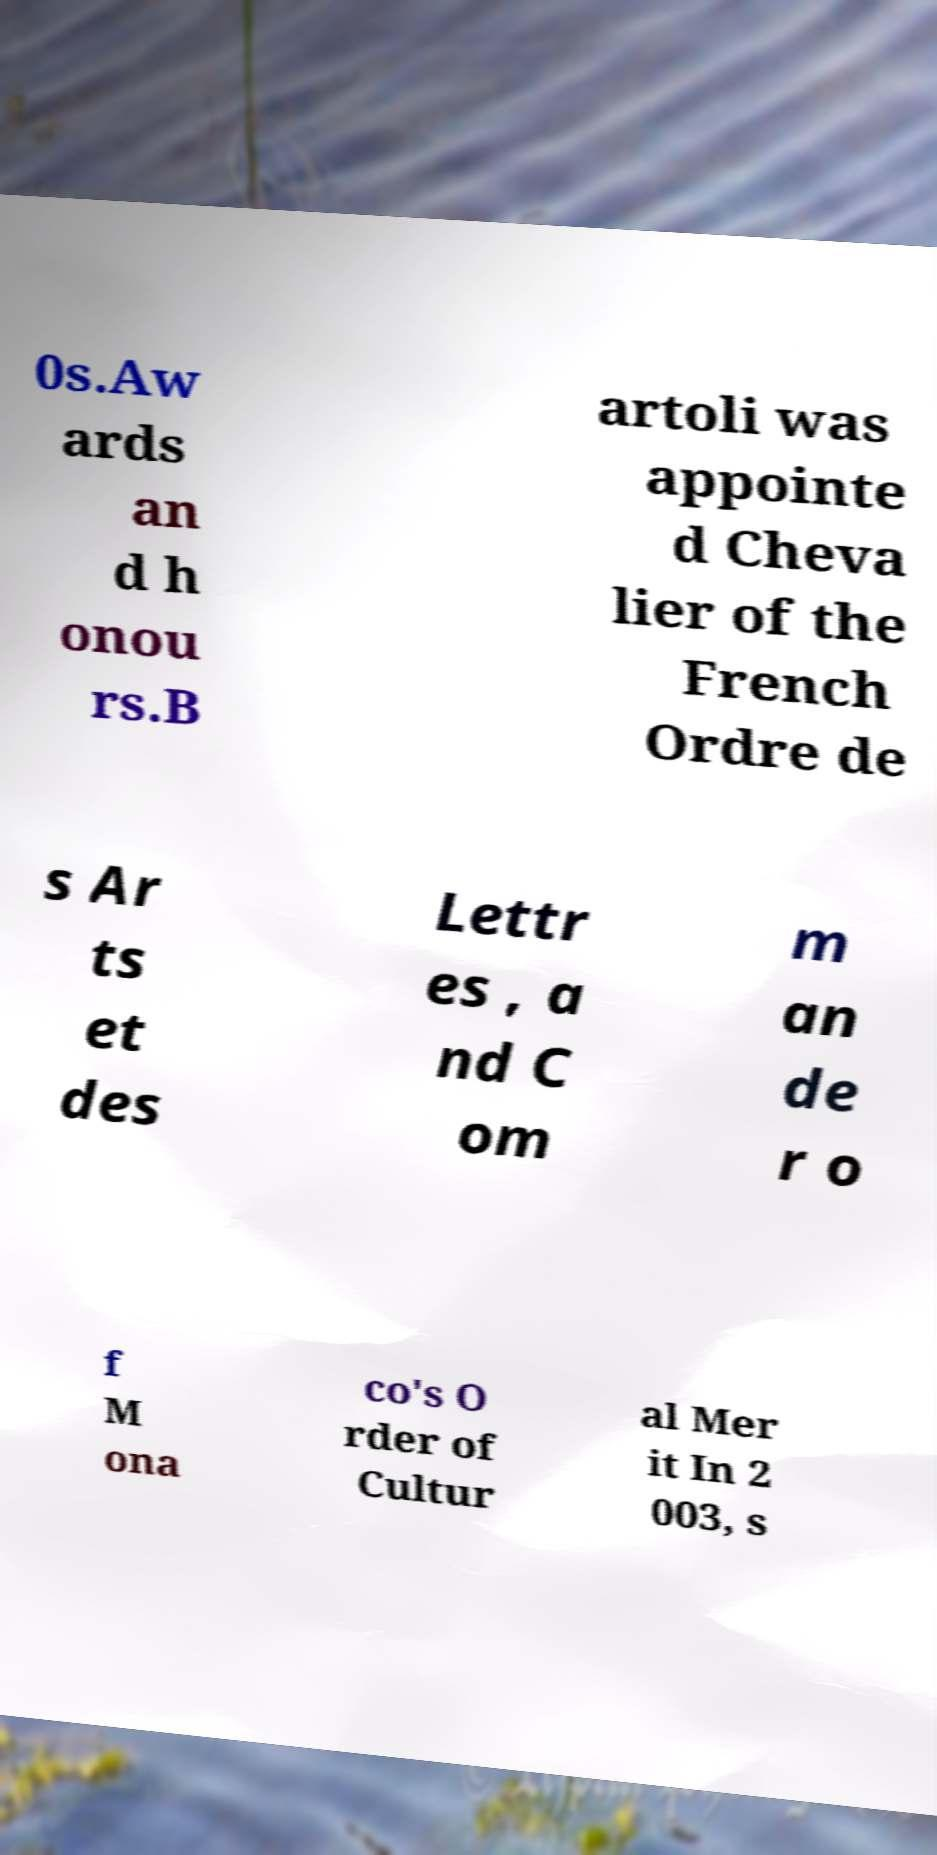Could you assist in decoding the text presented in this image and type it out clearly? 0s.Aw ards an d h onou rs.B artoli was appointe d Cheva lier of the French Ordre de s Ar ts et des Lettr es , a nd C om m an de r o f M ona co's O rder of Cultur al Mer it In 2 003, s 